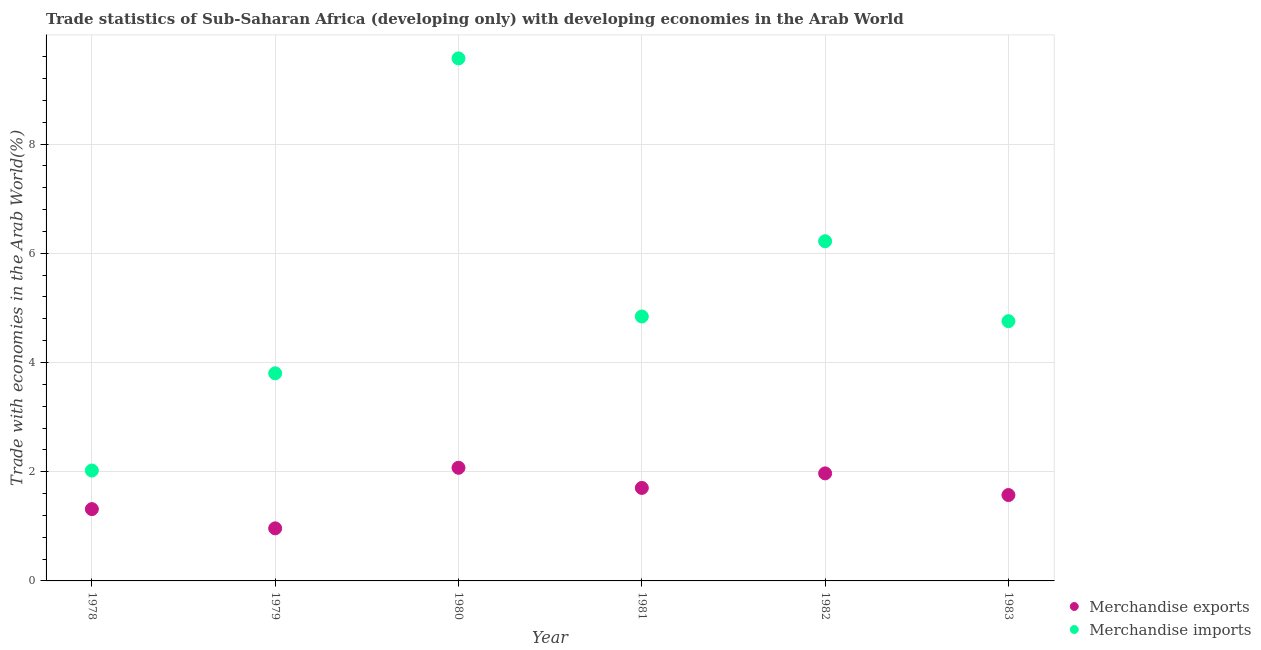How many different coloured dotlines are there?
Keep it short and to the point. 2. What is the merchandise imports in 1979?
Provide a succinct answer. 3.8. Across all years, what is the maximum merchandise exports?
Ensure brevity in your answer.  2.07. Across all years, what is the minimum merchandise exports?
Ensure brevity in your answer.  0.96. In which year was the merchandise exports minimum?
Your answer should be compact. 1979. What is the total merchandise exports in the graph?
Offer a very short reply. 9.59. What is the difference between the merchandise exports in 1978 and that in 1981?
Give a very brief answer. -0.39. What is the difference between the merchandise imports in 1978 and the merchandise exports in 1980?
Your answer should be very brief. -0.05. What is the average merchandise exports per year?
Keep it short and to the point. 1.6. In the year 1980, what is the difference between the merchandise exports and merchandise imports?
Make the answer very short. -7.5. In how many years, is the merchandise imports greater than 0.8 %?
Provide a succinct answer. 6. What is the ratio of the merchandise imports in 1978 to that in 1982?
Your answer should be very brief. 0.33. Is the difference between the merchandise imports in 1979 and 1983 greater than the difference between the merchandise exports in 1979 and 1983?
Make the answer very short. No. What is the difference between the highest and the second highest merchandise imports?
Provide a succinct answer. 3.35. What is the difference between the highest and the lowest merchandise exports?
Provide a short and direct response. 1.11. In how many years, is the merchandise exports greater than the average merchandise exports taken over all years?
Your answer should be very brief. 3. Is the sum of the merchandise exports in 1982 and 1983 greater than the maximum merchandise imports across all years?
Provide a short and direct response. No. Is the merchandise exports strictly less than the merchandise imports over the years?
Your response must be concise. Yes. How many dotlines are there?
Offer a very short reply. 2. What is the difference between two consecutive major ticks on the Y-axis?
Keep it short and to the point. 2. Where does the legend appear in the graph?
Your answer should be compact. Bottom right. How many legend labels are there?
Your response must be concise. 2. What is the title of the graph?
Provide a short and direct response. Trade statistics of Sub-Saharan Africa (developing only) with developing economies in the Arab World. Does "Current education expenditure" appear as one of the legend labels in the graph?
Ensure brevity in your answer.  No. What is the label or title of the Y-axis?
Give a very brief answer. Trade with economies in the Arab World(%). What is the Trade with economies in the Arab World(%) of Merchandise exports in 1978?
Offer a very short reply. 1.31. What is the Trade with economies in the Arab World(%) of Merchandise imports in 1978?
Provide a succinct answer. 2.02. What is the Trade with economies in the Arab World(%) of Merchandise exports in 1979?
Your answer should be very brief. 0.96. What is the Trade with economies in the Arab World(%) of Merchandise imports in 1979?
Provide a succinct answer. 3.8. What is the Trade with economies in the Arab World(%) of Merchandise exports in 1980?
Offer a terse response. 2.07. What is the Trade with economies in the Arab World(%) of Merchandise imports in 1980?
Offer a very short reply. 9.57. What is the Trade with economies in the Arab World(%) in Merchandise exports in 1981?
Offer a very short reply. 1.7. What is the Trade with economies in the Arab World(%) of Merchandise imports in 1981?
Offer a terse response. 4.84. What is the Trade with economies in the Arab World(%) of Merchandise exports in 1982?
Your answer should be compact. 1.97. What is the Trade with economies in the Arab World(%) in Merchandise imports in 1982?
Your answer should be very brief. 6.22. What is the Trade with economies in the Arab World(%) in Merchandise exports in 1983?
Keep it short and to the point. 1.57. What is the Trade with economies in the Arab World(%) of Merchandise imports in 1983?
Provide a short and direct response. 4.76. Across all years, what is the maximum Trade with economies in the Arab World(%) of Merchandise exports?
Provide a short and direct response. 2.07. Across all years, what is the maximum Trade with economies in the Arab World(%) in Merchandise imports?
Make the answer very short. 9.57. Across all years, what is the minimum Trade with economies in the Arab World(%) in Merchandise exports?
Offer a terse response. 0.96. Across all years, what is the minimum Trade with economies in the Arab World(%) in Merchandise imports?
Provide a short and direct response. 2.02. What is the total Trade with economies in the Arab World(%) in Merchandise exports in the graph?
Provide a short and direct response. 9.59. What is the total Trade with economies in the Arab World(%) in Merchandise imports in the graph?
Provide a succinct answer. 31.21. What is the difference between the Trade with economies in the Arab World(%) of Merchandise exports in 1978 and that in 1979?
Give a very brief answer. 0.35. What is the difference between the Trade with economies in the Arab World(%) of Merchandise imports in 1978 and that in 1979?
Offer a terse response. -1.78. What is the difference between the Trade with economies in the Arab World(%) of Merchandise exports in 1978 and that in 1980?
Your response must be concise. -0.76. What is the difference between the Trade with economies in the Arab World(%) of Merchandise imports in 1978 and that in 1980?
Give a very brief answer. -7.55. What is the difference between the Trade with economies in the Arab World(%) of Merchandise exports in 1978 and that in 1981?
Provide a short and direct response. -0.39. What is the difference between the Trade with economies in the Arab World(%) of Merchandise imports in 1978 and that in 1981?
Your response must be concise. -2.82. What is the difference between the Trade with economies in the Arab World(%) of Merchandise exports in 1978 and that in 1982?
Your response must be concise. -0.65. What is the difference between the Trade with economies in the Arab World(%) of Merchandise imports in 1978 and that in 1982?
Ensure brevity in your answer.  -4.2. What is the difference between the Trade with economies in the Arab World(%) in Merchandise exports in 1978 and that in 1983?
Your answer should be compact. -0.26. What is the difference between the Trade with economies in the Arab World(%) of Merchandise imports in 1978 and that in 1983?
Provide a short and direct response. -2.73. What is the difference between the Trade with economies in the Arab World(%) of Merchandise exports in 1979 and that in 1980?
Offer a very short reply. -1.11. What is the difference between the Trade with economies in the Arab World(%) of Merchandise imports in 1979 and that in 1980?
Your answer should be very brief. -5.77. What is the difference between the Trade with economies in the Arab World(%) in Merchandise exports in 1979 and that in 1981?
Make the answer very short. -0.74. What is the difference between the Trade with economies in the Arab World(%) in Merchandise imports in 1979 and that in 1981?
Your response must be concise. -1.04. What is the difference between the Trade with economies in the Arab World(%) in Merchandise exports in 1979 and that in 1982?
Your answer should be very brief. -1.01. What is the difference between the Trade with economies in the Arab World(%) of Merchandise imports in 1979 and that in 1982?
Provide a succinct answer. -2.42. What is the difference between the Trade with economies in the Arab World(%) of Merchandise exports in 1979 and that in 1983?
Ensure brevity in your answer.  -0.61. What is the difference between the Trade with economies in the Arab World(%) in Merchandise imports in 1979 and that in 1983?
Make the answer very short. -0.96. What is the difference between the Trade with economies in the Arab World(%) in Merchandise exports in 1980 and that in 1981?
Make the answer very short. 0.37. What is the difference between the Trade with economies in the Arab World(%) in Merchandise imports in 1980 and that in 1981?
Offer a very short reply. 4.73. What is the difference between the Trade with economies in the Arab World(%) in Merchandise exports in 1980 and that in 1982?
Your response must be concise. 0.1. What is the difference between the Trade with economies in the Arab World(%) of Merchandise imports in 1980 and that in 1982?
Your response must be concise. 3.35. What is the difference between the Trade with economies in the Arab World(%) in Merchandise exports in 1980 and that in 1983?
Ensure brevity in your answer.  0.5. What is the difference between the Trade with economies in the Arab World(%) in Merchandise imports in 1980 and that in 1983?
Offer a very short reply. 4.81. What is the difference between the Trade with economies in the Arab World(%) in Merchandise exports in 1981 and that in 1982?
Offer a very short reply. -0.27. What is the difference between the Trade with economies in the Arab World(%) of Merchandise imports in 1981 and that in 1982?
Your answer should be compact. -1.38. What is the difference between the Trade with economies in the Arab World(%) of Merchandise exports in 1981 and that in 1983?
Your answer should be very brief. 0.13. What is the difference between the Trade with economies in the Arab World(%) of Merchandise imports in 1981 and that in 1983?
Make the answer very short. 0.09. What is the difference between the Trade with economies in the Arab World(%) of Merchandise exports in 1982 and that in 1983?
Provide a short and direct response. 0.4. What is the difference between the Trade with economies in the Arab World(%) in Merchandise imports in 1982 and that in 1983?
Your answer should be very brief. 1.46. What is the difference between the Trade with economies in the Arab World(%) in Merchandise exports in 1978 and the Trade with economies in the Arab World(%) in Merchandise imports in 1979?
Make the answer very short. -2.49. What is the difference between the Trade with economies in the Arab World(%) of Merchandise exports in 1978 and the Trade with economies in the Arab World(%) of Merchandise imports in 1980?
Offer a terse response. -8.25. What is the difference between the Trade with economies in the Arab World(%) in Merchandise exports in 1978 and the Trade with economies in the Arab World(%) in Merchandise imports in 1981?
Provide a succinct answer. -3.53. What is the difference between the Trade with economies in the Arab World(%) of Merchandise exports in 1978 and the Trade with economies in the Arab World(%) of Merchandise imports in 1982?
Ensure brevity in your answer.  -4.9. What is the difference between the Trade with economies in the Arab World(%) in Merchandise exports in 1978 and the Trade with economies in the Arab World(%) in Merchandise imports in 1983?
Offer a terse response. -3.44. What is the difference between the Trade with economies in the Arab World(%) in Merchandise exports in 1979 and the Trade with economies in the Arab World(%) in Merchandise imports in 1980?
Make the answer very short. -8.61. What is the difference between the Trade with economies in the Arab World(%) in Merchandise exports in 1979 and the Trade with economies in the Arab World(%) in Merchandise imports in 1981?
Make the answer very short. -3.88. What is the difference between the Trade with economies in the Arab World(%) in Merchandise exports in 1979 and the Trade with economies in the Arab World(%) in Merchandise imports in 1982?
Provide a succinct answer. -5.26. What is the difference between the Trade with economies in the Arab World(%) of Merchandise exports in 1979 and the Trade with economies in the Arab World(%) of Merchandise imports in 1983?
Give a very brief answer. -3.79. What is the difference between the Trade with economies in the Arab World(%) in Merchandise exports in 1980 and the Trade with economies in the Arab World(%) in Merchandise imports in 1981?
Your answer should be compact. -2.77. What is the difference between the Trade with economies in the Arab World(%) of Merchandise exports in 1980 and the Trade with economies in the Arab World(%) of Merchandise imports in 1982?
Your response must be concise. -4.15. What is the difference between the Trade with economies in the Arab World(%) of Merchandise exports in 1980 and the Trade with economies in the Arab World(%) of Merchandise imports in 1983?
Your response must be concise. -2.68. What is the difference between the Trade with economies in the Arab World(%) in Merchandise exports in 1981 and the Trade with economies in the Arab World(%) in Merchandise imports in 1982?
Ensure brevity in your answer.  -4.52. What is the difference between the Trade with economies in the Arab World(%) in Merchandise exports in 1981 and the Trade with economies in the Arab World(%) in Merchandise imports in 1983?
Offer a very short reply. -3.05. What is the difference between the Trade with economies in the Arab World(%) in Merchandise exports in 1982 and the Trade with economies in the Arab World(%) in Merchandise imports in 1983?
Provide a short and direct response. -2.79. What is the average Trade with economies in the Arab World(%) in Merchandise exports per year?
Offer a very short reply. 1.6. What is the average Trade with economies in the Arab World(%) of Merchandise imports per year?
Your answer should be very brief. 5.2. In the year 1978, what is the difference between the Trade with economies in the Arab World(%) of Merchandise exports and Trade with economies in the Arab World(%) of Merchandise imports?
Provide a short and direct response. -0.71. In the year 1979, what is the difference between the Trade with economies in the Arab World(%) in Merchandise exports and Trade with economies in the Arab World(%) in Merchandise imports?
Your answer should be compact. -2.84. In the year 1980, what is the difference between the Trade with economies in the Arab World(%) of Merchandise exports and Trade with economies in the Arab World(%) of Merchandise imports?
Ensure brevity in your answer.  -7.5. In the year 1981, what is the difference between the Trade with economies in the Arab World(%) in Merchandise exports and Trade with economies in the Arab World(%) in Merchandise imports?
Offer a very short reply. -3.14. In the year 1982, what is the difference between the Trade with economies in the Arab World(%) of Merchandise exports and Trade with economies in the Arab World(%) of Merchandise imports?
Provide a short and direct response. -4.25. In the year 1983, what is the difference between the Trade with economies in the Arab World(%) in Merchandise exports and Trade with economies in the Arab World(%) in Merchandise imports?
Your response must be concise. -3.18. What is the ratio of the Trade with economies in the Arab World(%) of Merchandise exports in 1978 to that in 1979?
Ensure brevity in your answer.  1.37. What is the ratio of the Trade with economies in the Arab World(%) in Merchandise imports in 1978 to that in 1979?
Your response must be concise. 0.53. What is the ratio of the Trade with economies in the Arab World(%) in Merchandise exports in 1978 to that in 1980?
Offer a very short reply. 0.63. What is the ratio of the Trade with economies in the Arab World(%) in Merchandise imports in 1978 to that in 1980?
Ensure brevity in your answer.  0.21. What is the ratio of the Trade with economies in the Arab World(%) in Merchandise exports in 1978 to that in 1981?
Your answer should be very brief. 0.77. What is the ratio of the Trade with economies in the Arab World(%) of Merchandise imports in 1978 to that in 1981?
Offer a very short reply. 0.42. What is the ratio of the Trade with economies in the Arab World(%) of Merchandise exports in 1978 to that in 1982?
Your answer should be compact. 0.67. What is the ratio of the Trade with economies in the Arab World(%) in Merchandise imports in 1978 to that in 1982?
Offer a very short reply. 0.33. What is the ratio of the Trade with economies in the Arab World(%) in Merchandise exports in 1978 to that in 1983?
Make the answer very short. 0.84. What is the ratio of the Trade with economies in the Arab World(%) of Merchandise imports in 1978 to that in 1983?
Make the answer very short. 0.42. What is the ratio of the Trade with economies in the Arab World(%) of Merchandise exports in 1979 to that in 1980?
Give a very brief answer. 0.46. What is the ratio of the Trade with economies in the Arab World(%) in Merchandise imports in 1979 to that in 1980?
Your answer should be compact. 0.4. What is the ratio of the Trade with economies in the Arab World(%) in Merchandise exports in 1979 to that in 1981?
Ensure brevity in your answer.  0.57. What is the ratio of the Trade with economies in the Arab World(%) of Merchandise imports in 1979 to that in 1981?
Provide a short and direct response. 0.79. What is the ratio of the Trade with economies in the Arab World(%) in Merchandise exports in 1979 to that in 1982?
Your answer should be very brief. 0.49. What is the ratio of the Trade with economies in the Arab World(%) in Merchandise imports in 1979 to that in 1982?
Your answer should be very brief. 0.61. What is the ratio of the Trade with economies in the Arab World(%) of Merchandise exports in 1979 to that in 1983?
Your response must be concise. 0.61. What is the ratio of the Trade with economies in the Arab World(%) of Merchandise imports in 1979 to that in 1983?
Make the answer very short. 0.8. What is the ratio of the Trade with economies in the Arab World(%) in Merchandise exports in 1980 to that in 1981?
Provide a succinct answer. 1.22. What is the ratio of the Trade with economies in the Arab World(%) in Merchandise imports in 1980 to that in 1981?
Your answer should be very brief. 1.98. What is the ratio of the Trade with economies in the Arab World(%) of Merchandise exports in 1980 to that in 1982?
Your answer should be very brief. 1.05. What is the ratio of the Trade with economies in the Arab World(%) of Merchandise imports in 1980 to that in 1982?
Provide a succinct answer. 1.54. What is the ratio of the Trade with economies in the Arab World(%) of Merchandise exports in 1980 to that in 1983?
Your response must be concise. 1.32. What is the ratio of the Trade with economies in the Arab World(%) of Merchandise imports in 1980 to that in 1983?
Ensure brevity in your answer.  2.01. What is the ratio of the Trade with economies in the Arab World(%) in Merchandise exports in 1981 to that in 1982?
Offer a very short reply. 0.86. What is the ratio of the Trade with economies in the Arab World(%) of Merchandise imports in 1981 to that in 1982?
Give a very brief answer. 0.78. What is the ratio of the Trade with economies in the Arab World(%) in Merchandise exports in 1981 to that in 1983?
Offer a very short reply. 1.08. What is the ratio of the Trade with economies in the Arab World(%) in Merchandise imports in 1981 to that in 1983?
Make the answer very short. 1.02. What is the ratio of the Trade with economies in the Arab World(%) in Merchandise exports in 1982 to that in 1983?
Provide a short and direct response. 1.25. What is the ratio of the Trade with economies in the Arab World(%) of Merchandise imports in 1982 to that in 1983?
Offer a terse response. 1.31. What is the difference between the highest and the second highest Trade with economies in the Arab World(%) in Merchandise exports?
Your answer should be very brief. 0.1. What is the difference between the highest and the second highest Trade with economies in the Arab World(%) in Merchandise imports?
Provide a succinct answer. 3.35. What is the difference between the highest and the lowest Trade with economies in the Arab World(%) of Merchandise exports?
Keep it short and to the point. 1.11. What is the difference between the highest and the lowest Trade with economies in the Arab World(%) of Merchandise imports?
Your response must be concise. 7.55. 